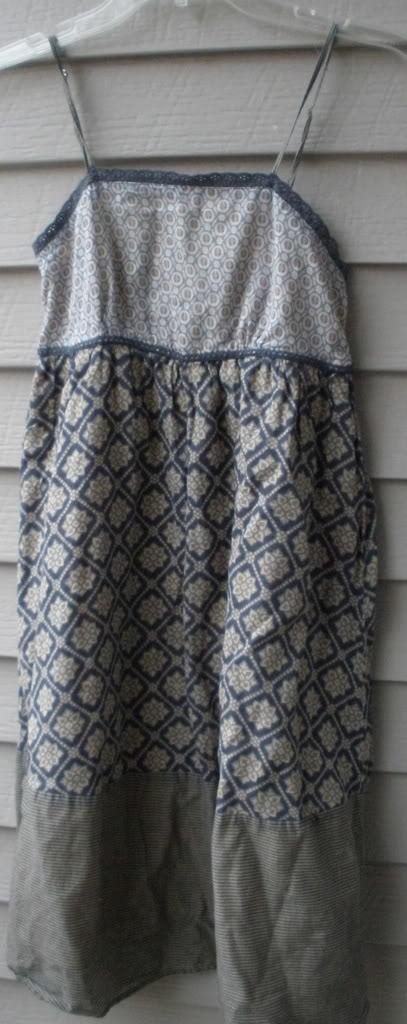Please provide a concise description of this image. In this image we can see a dress hanging to the hanger. 